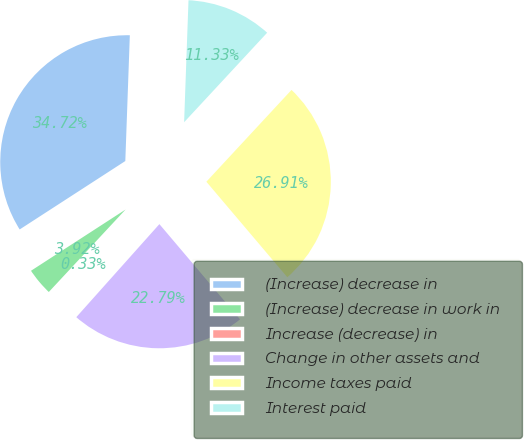Convert chart to OTSL. <chart><loc_0><loc_0><loc_500><loc_500><pie_chart><fcel>(Increase) decrease in<fcel>(Increase) decrease in work in<fcel>Increase (decrease) in<fcel>Change in other assets and<fcel>Income taxes paid<fcel>Interest paid<nl><fcel>34.72%<fcel>3.92%<fcel>0.33%<fcel>22.79%<fcel>26.91%<fcel>11.33%<nl></chart> 